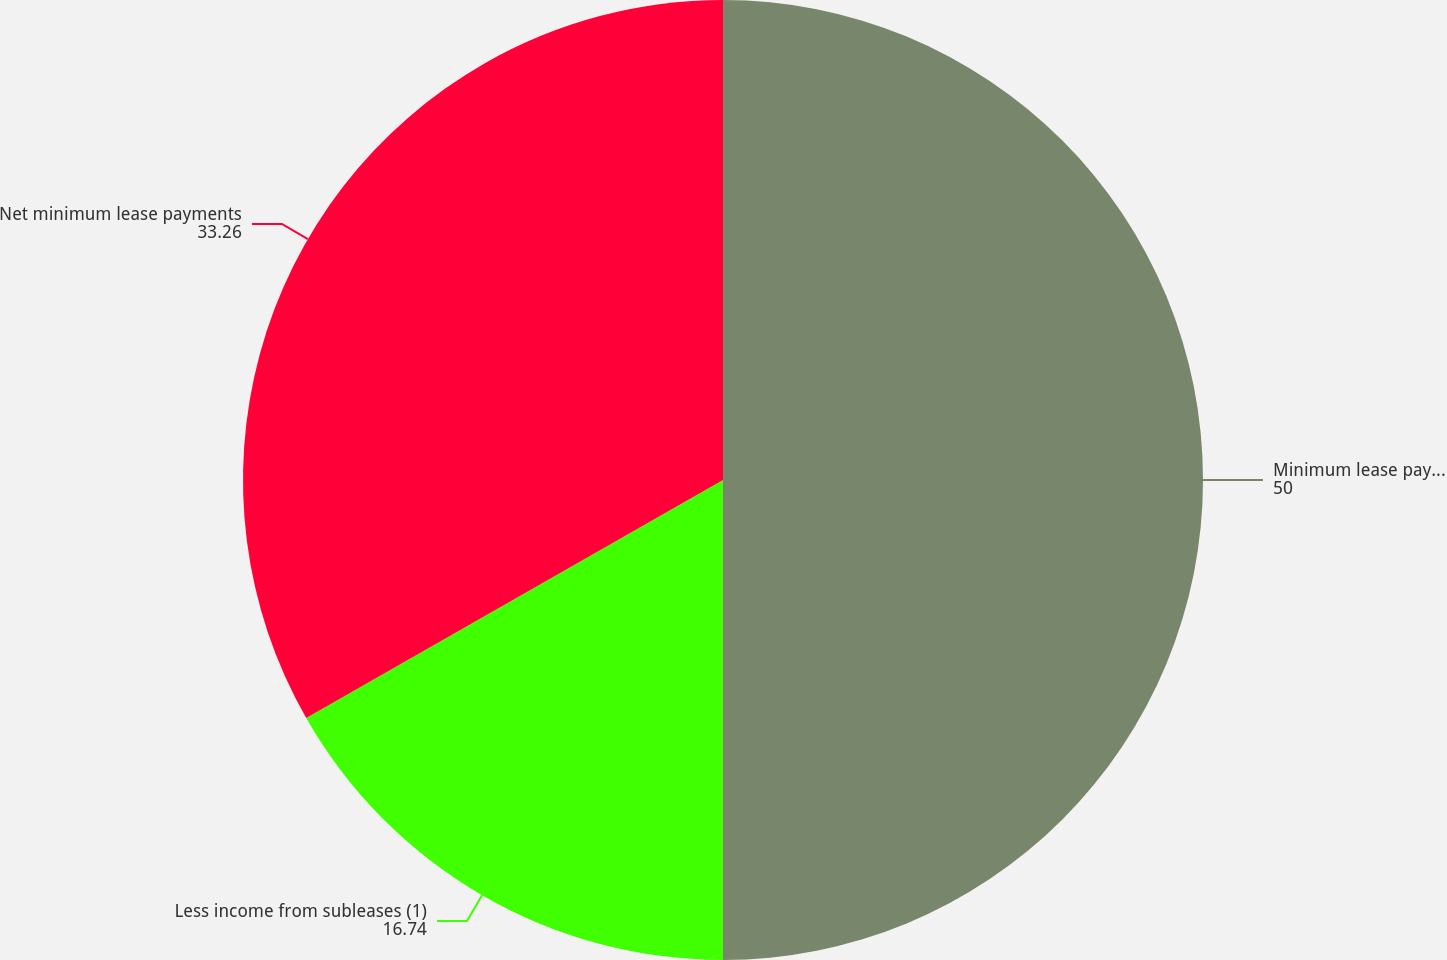<chart> <loc_0><loc_0><loc_500><loc_500><pie_chart><fcel>Minimum lease payments<fcel>Less income from subleases (1)<fcel>Net minimum lease payments<nl><fcel>50.0%<fcel>16.74%<fcel>33.26%<nl></chart> 